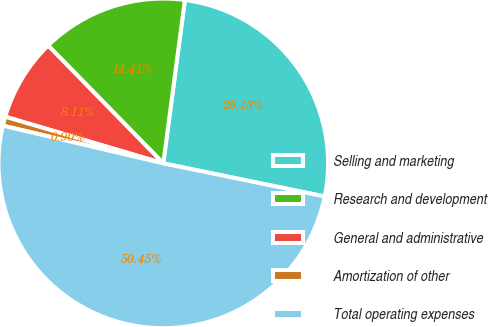Convert chart to OTSL. <chart><loc_0><loc_0><loc_500><loc_500><pie_chart><fcel>Selling and marketing<fcel>Research and development<fcel>General and administrative<fcel>Amortization of other<fcel>Total operating expenses<nl><fcel>26.13%<fcel>14.41%<fcel>8.11%<fcel>0.9%<fcel>50.45%<nl></chart> 